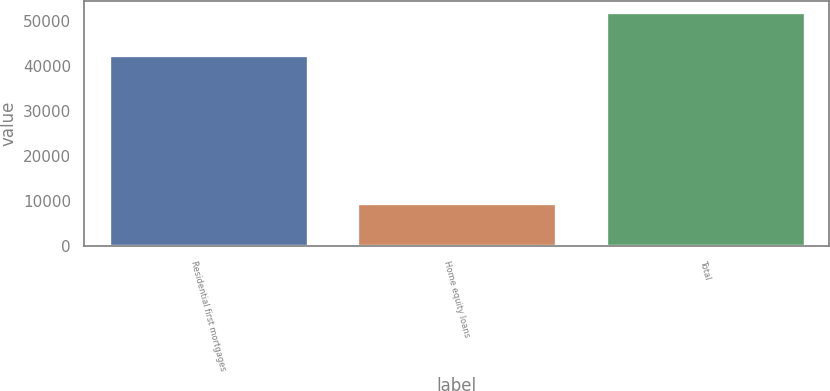Convert chart. <chart><loc_0><loc_0><loc_500><loc_500><bar_chart><fcel>Residential first mortgages<fcel>Home equity loans<fcel>Total<nl><fcel>42379<fcel>9465<fcel>51844<nl></chart> 